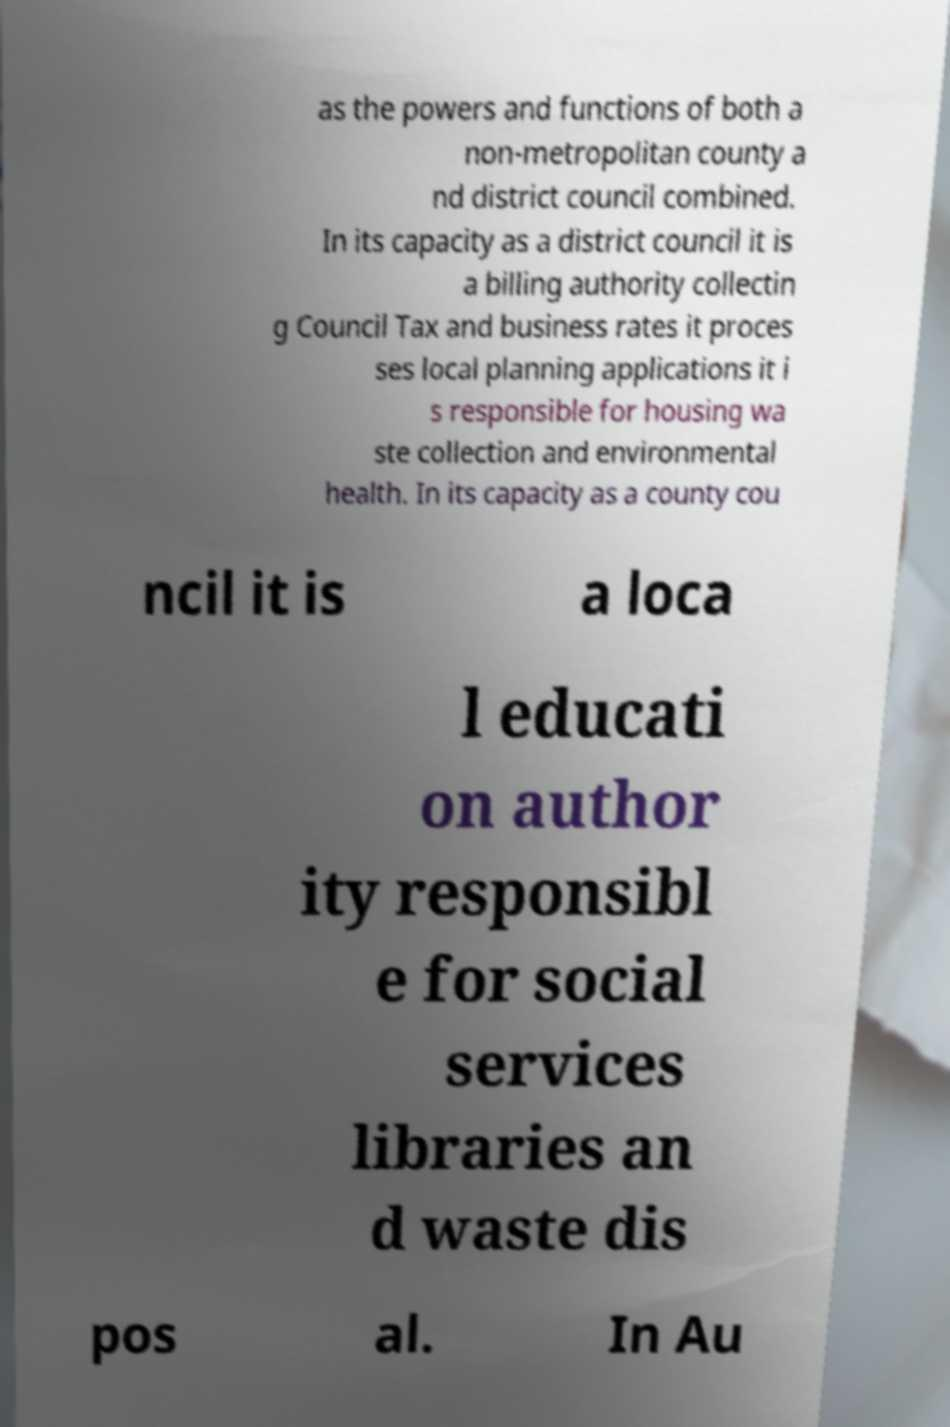Could you extract and type out the text from this image? as the powers and functions of both a non-metropolitan county a nd district council combined. In its capacity as a district council it is a billing authority collectin g Council Tax and business rates it proces ses local planning applications it i s responsible for housing wa ste collection and environmental health. In its capacity as a county cou ncil it is a loca l educati on author ity responsibl e for social services libraries an d waste dis pos al. In Au 